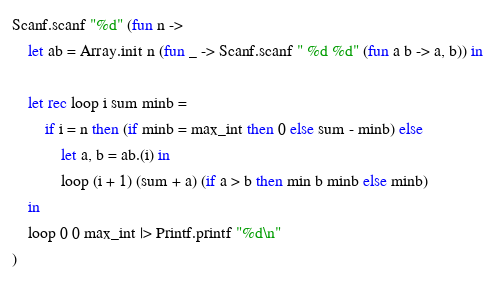Convert code to text. <code><loc_0><loc_0><loc_500><loc_500><_OCaml_>Scanf.scanf "%d" (fun n ->
    let ab = Array.init n (fun _ -> Scanf.scanf " %d %d" (fun a b -> a, b)) in

    let rec loop i sum minb =
        if i = n then (if minb = max_int then 0 else sum - minb) else
            let a, b = ab.(i) in
            loop (i + 1) (sum + a) (if a > b then min b minb else minb)
    in
    loop 0 0 max_int |> Printf.printf "%d\n"
)</code> 